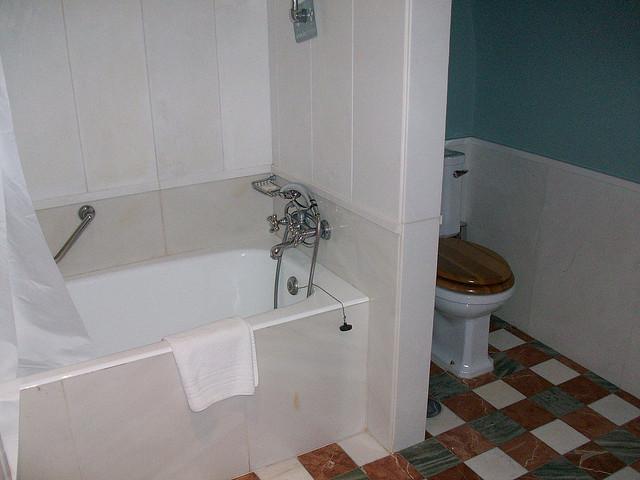Will a tree grow from the toilet seat cover?
Answer briefly. No. Are all the tiles white?
Be succinct. No. Is the toilet seat cover a soft seat cover?
Keep it brief. No. How many bars are there?
Be succinct. 1. Is the restroom designed for a handicapped person to use?
Answer briefly. No. Does the bathtub have a rail?
Quick response, please. Yes. 